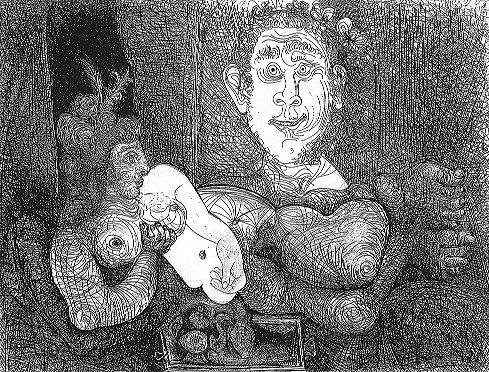What could the number 6 on the card symbolize in this context? In the context of this surreal artwork, the number 6 may hold multiple layers of symbolism. Often considered a number of harmony and balance, it might represent the equilibrium between reality and fantasy within this scene. Alternatively, as surreal art often evokes deep and personal responses, the number could also be a clue left by the artist to suggest a more personal or hidden meaning, perhaps relating to a significant event or theme in the artist's life or in cultural symbolism. 